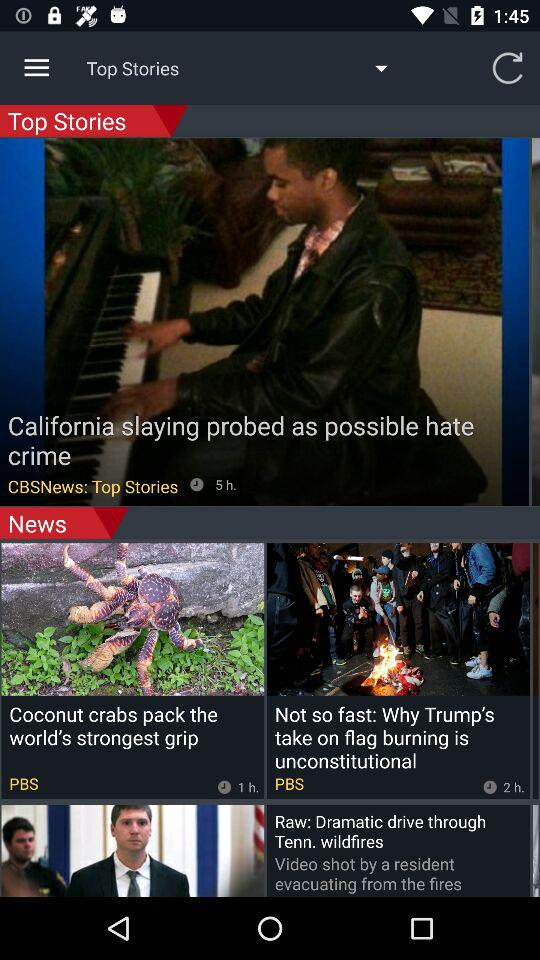When was the Coconut crabs' pack the world's strongest grip news uploaded? The news about Coconut crabs' pack the world's strongest grip was uploaded 1 hour ago. 